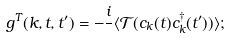<formula> <loc_0><loc_0><loc_500><loc_500>g ^ { T } ( { k } , t , t ^ { \prime } ) = - \frac { i } { } \langle \mathcal { T } ( c _ { k } ( t ) c _ { k } ^ { \dagger } ( t ^ { \prime } ) ) \rangle ;</formula> 